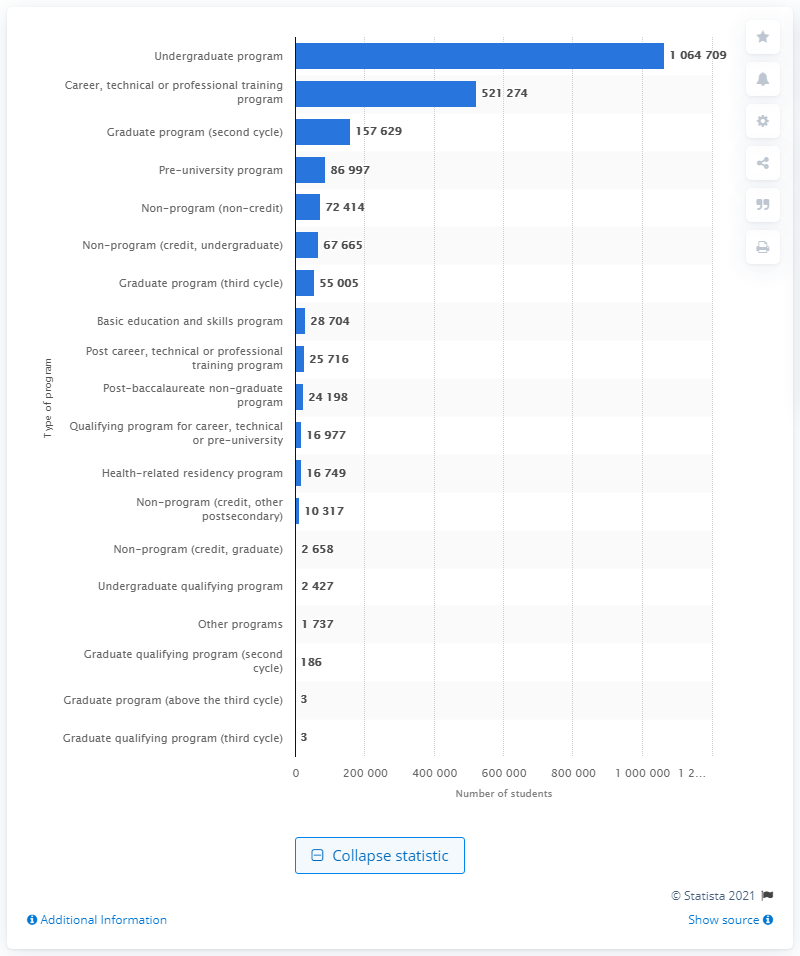Highlight a few significant elements in this photo. In 2019, there were 1,064,709 students enrolled in undergraduate programs in Canada. 